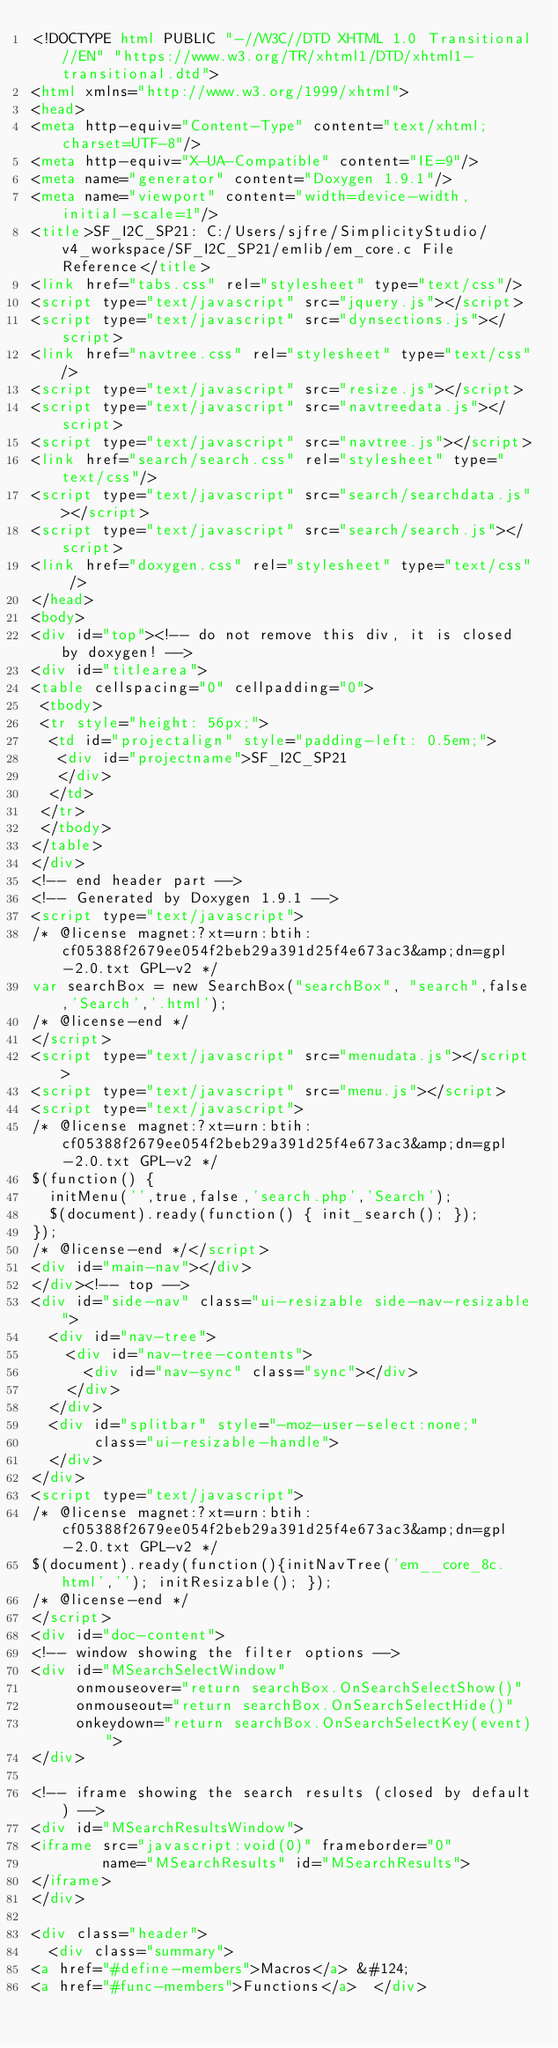<code> <loc_0><loc_0><loc_500><loc_500><_HTML_><!DOCTYPE html PUBLIC "-//W3C//DTD XHTML 1.0 Transitional//EN" "https://www.w3.org/TR/xhtml1/DTD/xhtml1-transitional.dtd">
<html xmlns="http://www.w3.org/1999/xhtml">
<head>
<meta http-equiv="Content-Type" content="text/xhtml;charset=UTF-8"/>
<meta http-equiv="X-UA-Compatible" content="IE=9"/>
<meta name="generator" content="Doxygen 1.9.1"/>
<meta name="viewport" content="width=device-width, initial-scale=1"/>
<title>SF_I2C_SP21: C:/Users/sjfre/SimplicityStudio/v4_workspace/SF_I2C_SP21/emlib/em_core.c File Reference</title>
<link href="tabs.css" rel="stylesheet" type="text/css"/>
<script type="text/javascript" src="jquery.js"></script>
<script type="text/javascript" src="dynsections.js"></script>
<link href="navtree.css" rel="stylesheet" type="text/css"/>
<script type="text/javascript" src="resize.js"></script>
<script type="text/javascript" src="navtreedata.js"></script>
<script type="text/javascript" src="navtree.js"></script>
<link href="search/search.css" rel="stylesheet" type="text/css"/>
<script type="text/javascript" src="search/searchdata.js"></script>
<script type="text/javascript" src="search/search.js"></script>
<link href="doxygen.css" rel="stylesheet" type="text/css" />
</head>
<body>
<div id="top"><!-- do not remove this div, it is closed by doxygen! -->
<div id="titlearea">
<table cellspacing="0" cellpadding="0">
 <tbody>
 <tr style="height: 56px;">
  <td id="projectalign" style="padding-left: 0.5em;">
   <div id="projectname">SF_I2C_SP21
   </div>
  </td>
 </tr>
 </tbody>
</table>
</div>
<!-- end header part -->
<!-- Generated by Doxygen 1.9.1 -->
<script type="text/javascript">
/* @license magnet:?xt=urn:btih:cf05388f2679ee054f2beb29a391d25f4e673ac3&amp;dn=gpl-2.0.txt GPL-v2 */
var searchBox = new SearchBox("searchBox", "search",false,'Search','.html');
/* @license-end */
</script>
<script type="text/javascript" src="menudata.js"></script>
<script type="text/javascript" src="menu.js"></script>
<script type="text/javascript">
/* @license magnet:?xt=urn:btih:cf05388f2679ee054f2beb29a391d25f4e673ac3&amp;dn=gpl-2.0.txt GPL-v2 */
$(function() {
  initMenu('',true,false,'search.php','Search');
  $(document).ready(function() { init_search(); });
});
/* @license-end */</script>
<div id="main-nav"></div>
</div><!-- top -->
<div id="side-nav" class="ui-resizable side-nav-resizable">
  <div id="nav-tree">
    <div id="nav-tree-contents">
      <div id="nav-sync" class="sync"></div>
    </div>
  </div>
  <div id="splitbar" style="-moz-user-select:none;" 
       class="ui-resizable-handle">
  </div>
</div>
<script type="text/javascript">
/* @license magnet:?xt=urn:btih:cf05388f2679ee054f2beb29a391d25f4e673ac3&amp;dn=gpl-2.0.txt GPL-v2 */
$(document).ready(function(){initNavTree('em__core_8c.html',''); initResizable(); });
/* @license-end */
</script>
<div id="doc-content">
<!-- window showing the filter options -->
<div id="MSearchSelectWindow"
     onmouseover="return searchBox.OnSearchSelectShow()"
     onmouseout="return searchBox.OnSearchSelectHide()"
     onkeydown="return searchBox.OnSearchSelectKey(event)">
</div>

<!-- iframe showing the search results (closed by default) -->
<div id="MSearchResultsWindow">
<iframe src="javascript:void(0)" frameborder="0" 
        name="MSearchResults" id="MSearchResults">
</iframe>
</div>

<div class="header">
  <div class="summary">
<a href="#define-members">Macros</a> &#124;
<a href="#func-members">Functions</a>  </div></code> 